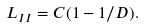<formula> <loc_0><loc_0><loc_500><loc_500>L _ { I I } = C ( 1 - 1 / D ) .</formula> 